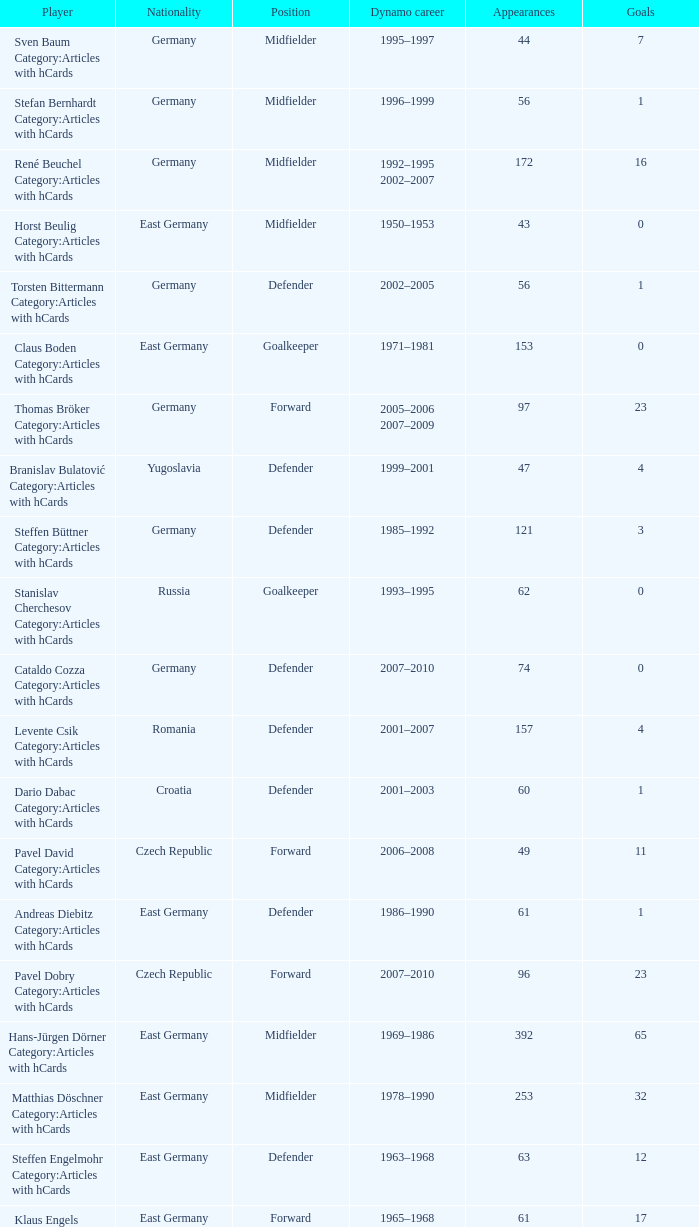What was the position of the player with 57 goals? Forward. 